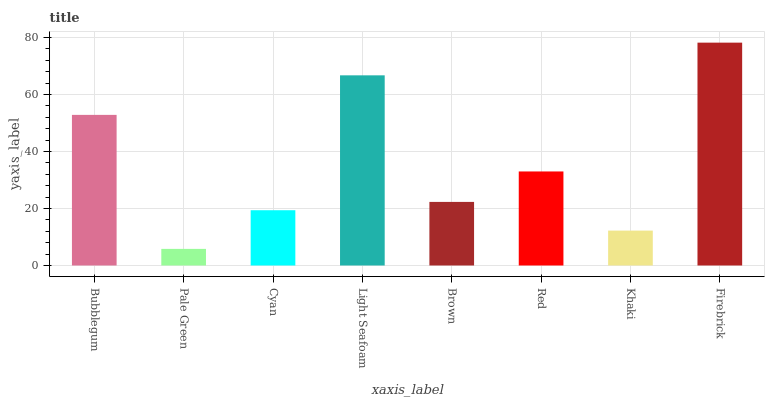Is Pale Green the minimum?
Answer yes or no. Yes. Is Firebrick the maximum?
Answer yes or no. Yes. Is Cyan the minimum?
Answer yes or no. No. Is Cyan the maximum?
Answer yes or no. No. Is Cyan greater than Pale Green?
Answer yes or no. Yes. Is Pale Green less than Cyan?
Answer yes or no. Yes. Is Pale Green greater than Cyan?
Answer yes or no. No. Is Cyan less than Pale Green?
Answer yes or no. No. Is Red the high median?
Answer yes or no. Yes. Is Brown the low median?
Answer yes or no. Yes. Is Firebrick the high median?
Answer yes or no. No. Is Khaki the low median?
Answer yes or no. No. 